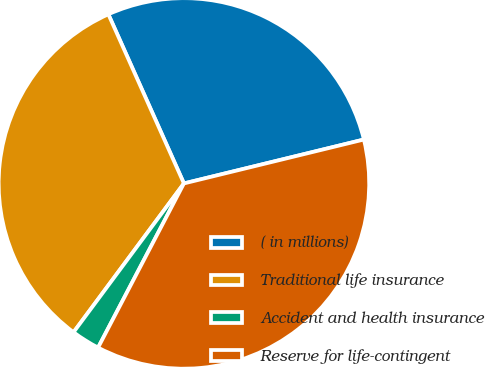Convert chart to OTSL. <chart><loc_0><loc_0><loc_500><loc_500><pie_chart><fcel>( in millions)<fcel>Traditional life insurance<fcel>Accident and health insurance<fcel>Reserve for life-contingent<nl><fcel>27.88%<fcel>33.16%<fcel>2.49%<fcel>36.48%<nl></chart> 